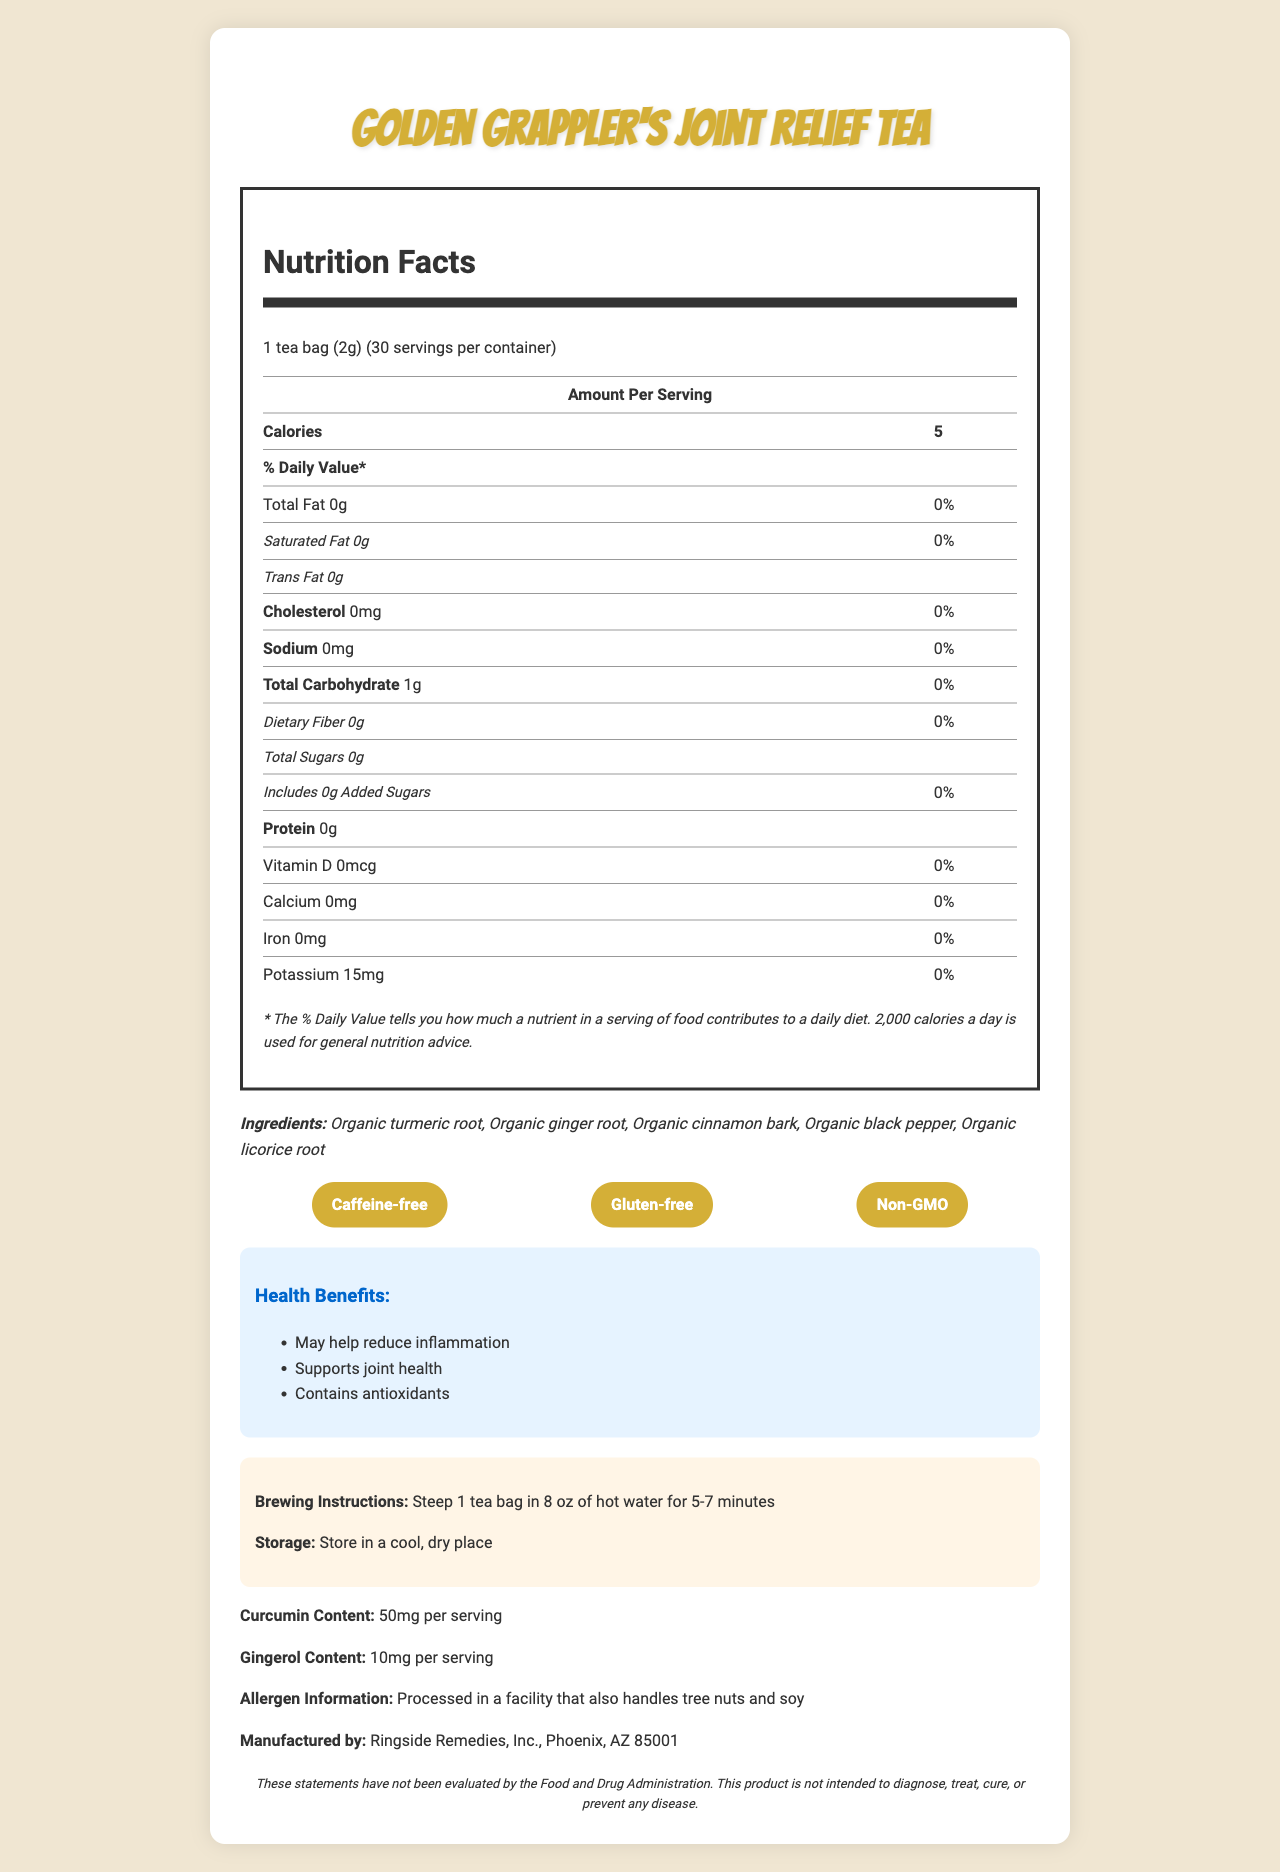what is the serving size of the tea? The document explicitly states that the serving size is 1 tea bag weighing 2 grams.
Answer: 1 tea bag (2g) how many servings are in one container of the tea? The document specifies that there are 30 servings per container.
Answer: 30 servings how many calories are in each serving of the tea? According to the document, each serving of the tea contains 5 calories.
Answer: 5 calories what are the main ingredients in the tea? The ingredients section of the document lists these five main organic ingredients.
Answer: Organic turmeric root, Organic ginger root, Organic cinnamon bark, Organic black pepper, Organic licorice root does this tea contain any caffeine? The document mentions the special feature "Caffeine-free," indicating that the tea does not contain caffeine.
Answer: No what is the curcumin content per serving? A. 10mg B. 20mg C. 50mg D. 100mg The document states that the curcumin content is 50mg per serving.
Answer: C. 50mg what health benefits does this tea claim to offer? A. Reduces inflammation B. Supports joint health C. Contains antioxidants D. All of the above The health claims section lists all three benefits: may help reduce inflammation, supports joint health, and contains antioxidants.
Answer: D. All of the above is the tea gluten-free? The document highlights "Gluten-free" as one of the special features.
Answer: Yes does the tea contain any added sugars? The nutrition facts explicitly state that the tea contains 0 grams of added sugars.
Answer: No which company manufactures this tea? The manufacturer's information at the bottom of the document indicates that Ringside Remedies, Inc. produces this tea.
Answer: Ringside Remedies, Inc., Phoenix, AZ 85001 are there any potential allergens mentioned in the document? The allergen information states that the tea is processed in a facility that also handles tree nuts and soy.
Answer: Yes what is the main idea of the document? The document covers various aspects of the product, from nutrition facts to health benefits and usage instructions, focusing on how the tea can assist with inflammation and joint health.
Answer: The document provides detailed nutritional information, ingredient details, special features, health benefits, and usage instructions for "Golden Grappler's Joint Relief Tea" which is designed to help reduce inflammation and support joint health. what is the main source of carbohydrates in the tea? The document lists the total carbohydrate content but does not specify the source of the carbohydrates.
Answer: Not enough information 